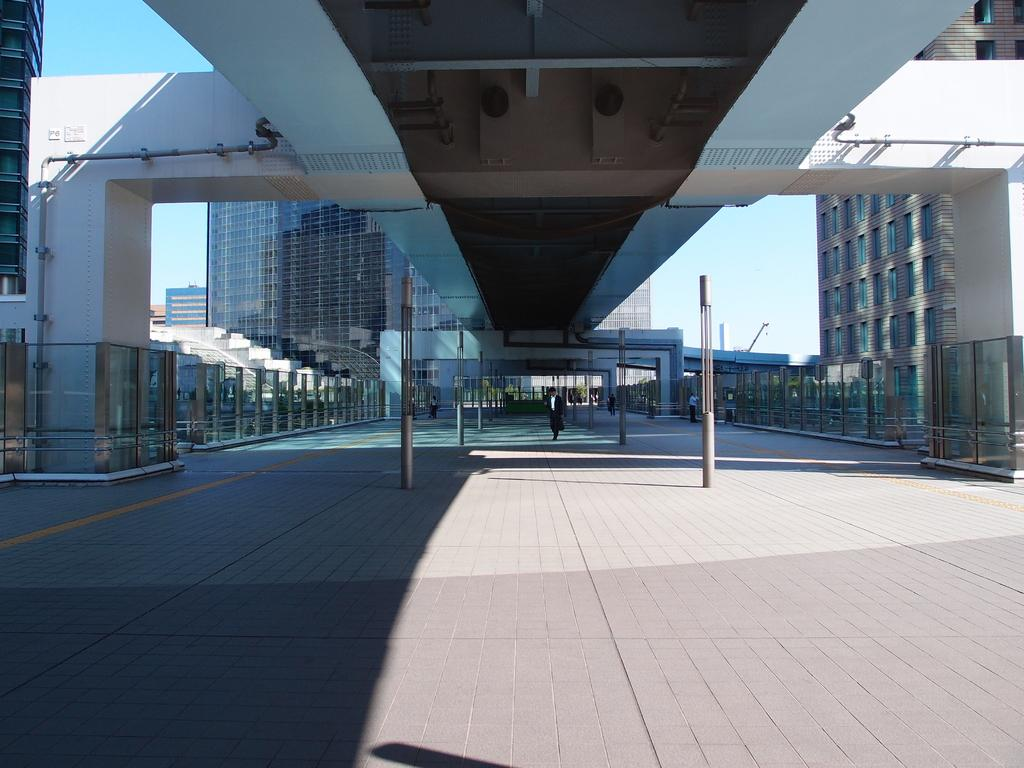What is the person in the image doing? There is a person walking on the road in the image. What structures can be seen in the image? Poles, glass walls, pillars, and glass buildings are visible in the image. What is the background of the image? The sky is visible in the background of the image. What type of pies are being served at the waste disposal site in the image? There is no mention of pies or a waste disposal site in the image; it features a person walking on the road with various structures and the sky in the background. 